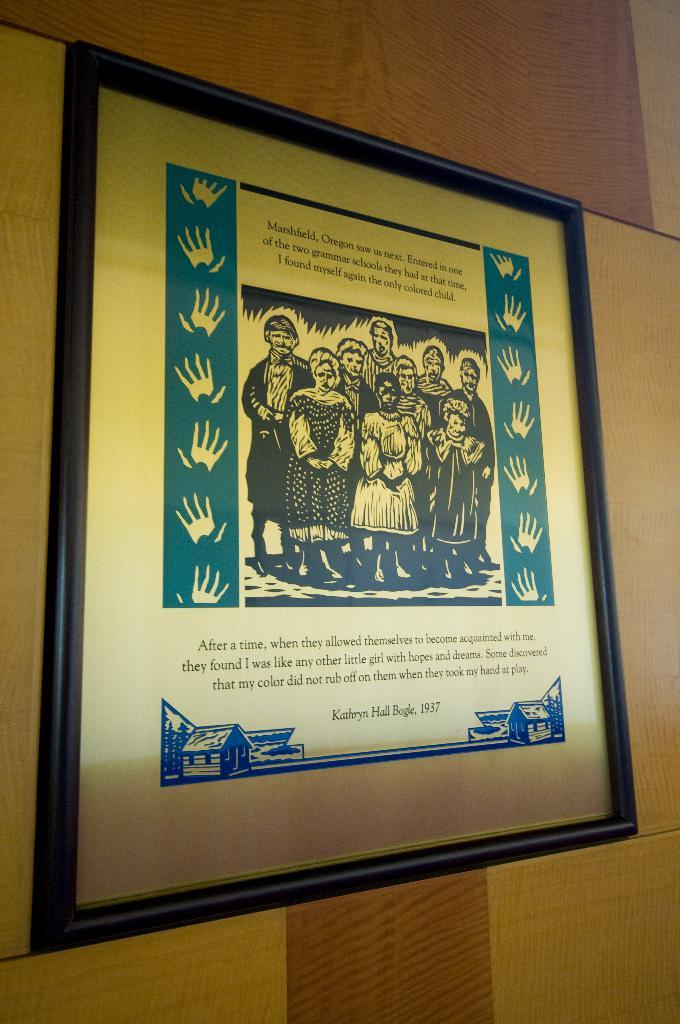<image>
Summarize the visual content of the image. a poster with wood cut prints reading Marshfield, Oregon on it 